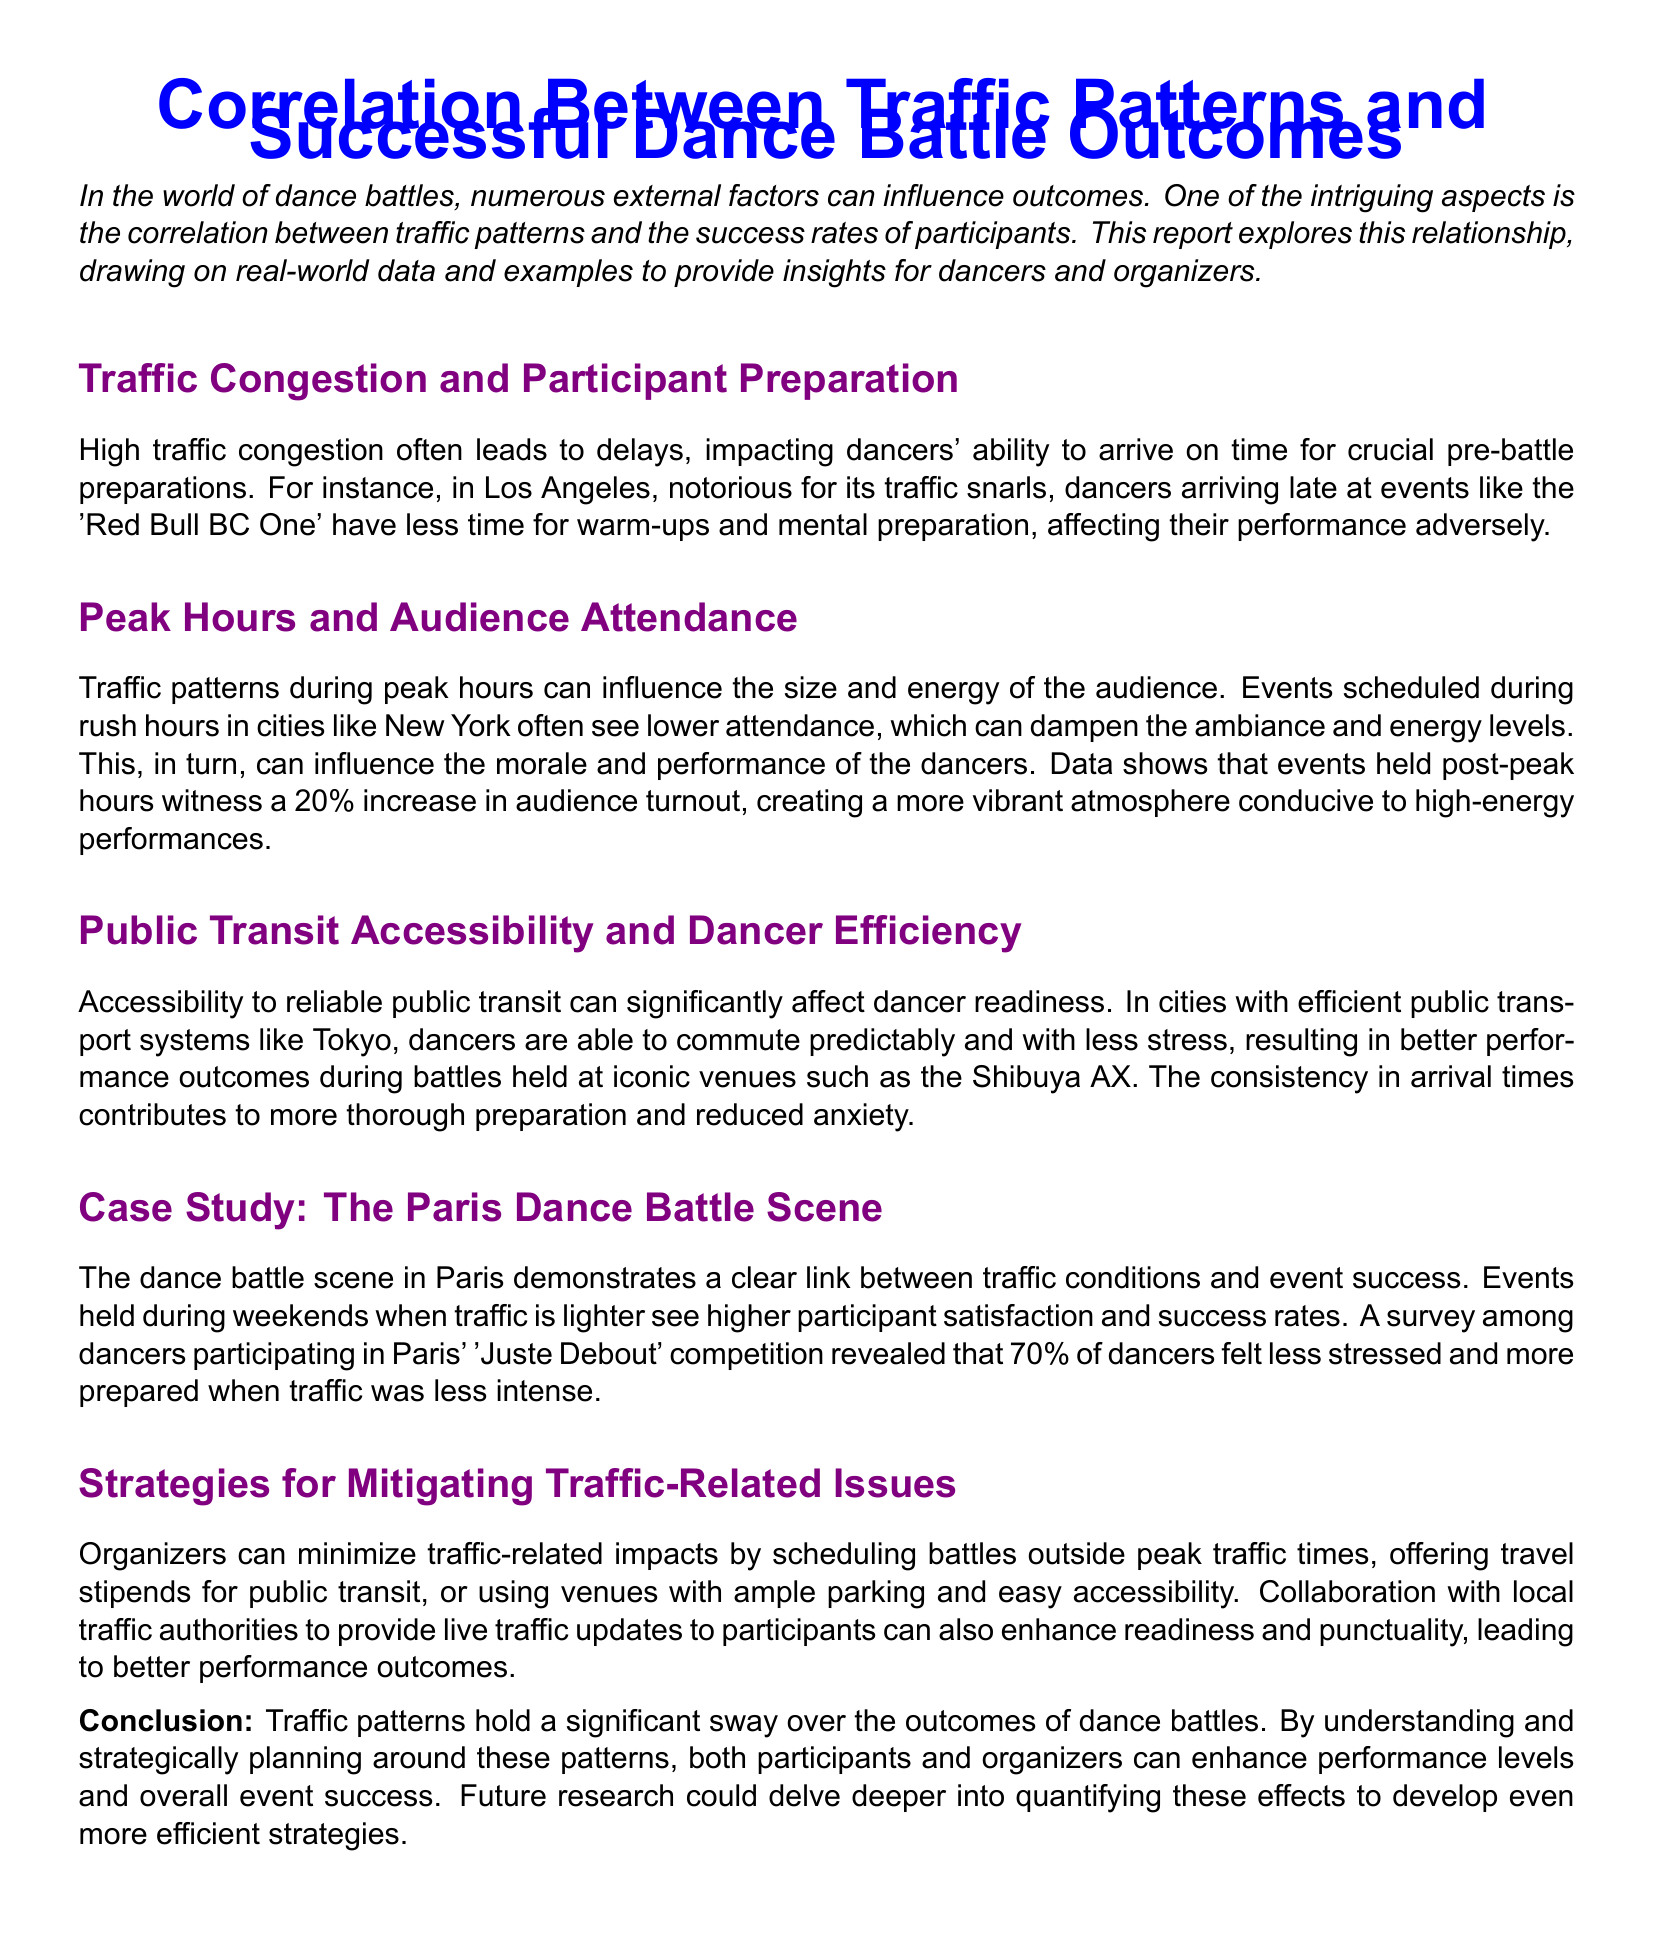What event is mentioned in relation to Los Angeles traffic? The report states that dancers arriving late at events like the 'Red Bull BC One' in Los Angeles experience negative impacts on their performance due to traffic congestion.
Answer: 'Red Bull BC One' What percentage increase in audience turnout is noted for events held post-peak hours? The document mentions a 20% increase in audience turnout for events held after peak hours, which contributes to a more vibrant atmosphere.
Answer: 20% How do efficient public transit systems impact dancer performance? The document explains that in cities with efficient public transport, like Tokyo, dancers commute predictably and with less stress, leading to better performance outcomes.
Answer: Better performance outcomes What is the primary cause of lower audience attendance during dance battles in New York? The report discusses that events scheduled during rush hours often see lower attendance, dampening the ambiance and energy levels during the battles.
Answer: Rush hours What percentage of dancers felt less stressed during lighter traffic in Paris? According to the survey among dancers in Paris' 'Juste Debout' competition, 70% felt less stressed when traffic was less intense.
Answer: 70% Which city's dance battle venue is mentioned for its reliable public transit? The document notes that Tokyo is highlighted for its reliable public transport systems, impacting dancer readiness positively.
Answer: Tokyo What strategy can organizers use to reduce traffic-related issues? The report suggests that organizers could schedule battles outside peak traffic times as a strategy to minimize negative impacts on the events.
Answer: Schedule outside peak times What is the correlation explored in the report? The document explores the relationship between traffic patterns and the success rates of participants in dance battles.
Answer: Traffic patterns and success rates What advantage does scheduling events during weekends provide according to the Paris case study? The case study indicates that events held during weekends when traffic is lighter lead to higher participant satisfaction and success rates.
Answer: Higher participant satisfaction 